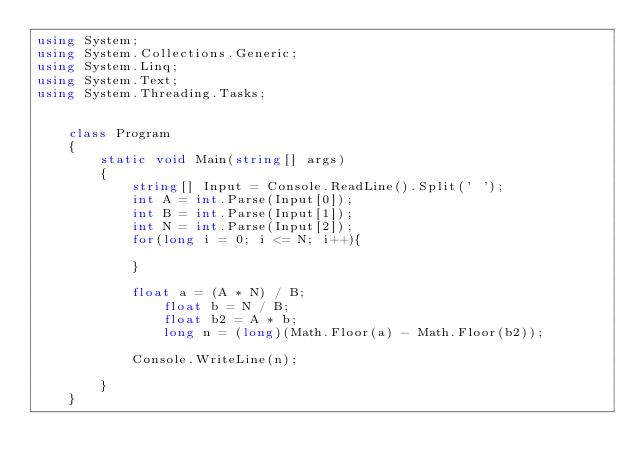Convert code to text. <code><loc_0><loc_0><loc_500><loc_500><_C#_>using System;
using System.Collections.Generic;
using System.Linq;
using System.Text;
using System.Threading.Tasks;


    class Program
    {
        static void Main(string[] args)
        {
            string[] Input = Console.ReadLine().Split(' ');
            int A = int.Parse(Input[0]);
            int B = int.Parse(Input[1]);
            int N = int.Parse(Input[2]);
            for(long i = 0; i <= N; i++){
                
            }
            
            float a = (A * N) / B;
                float b = N / B;
                float b2 = A * b;
                long n = (long)(Math.Floor(a) - Math.Floor(b2));
            
            Console.WriteLine(n);
            
        }
    }

</code> 